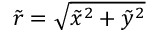<formula> <loc_0><loc_0><loc_500><loc_500>\tilde { r } = \sqrt { \tilde { x } ^ { 2 } + \tilde { y } ^ { 2 } }</formula> 